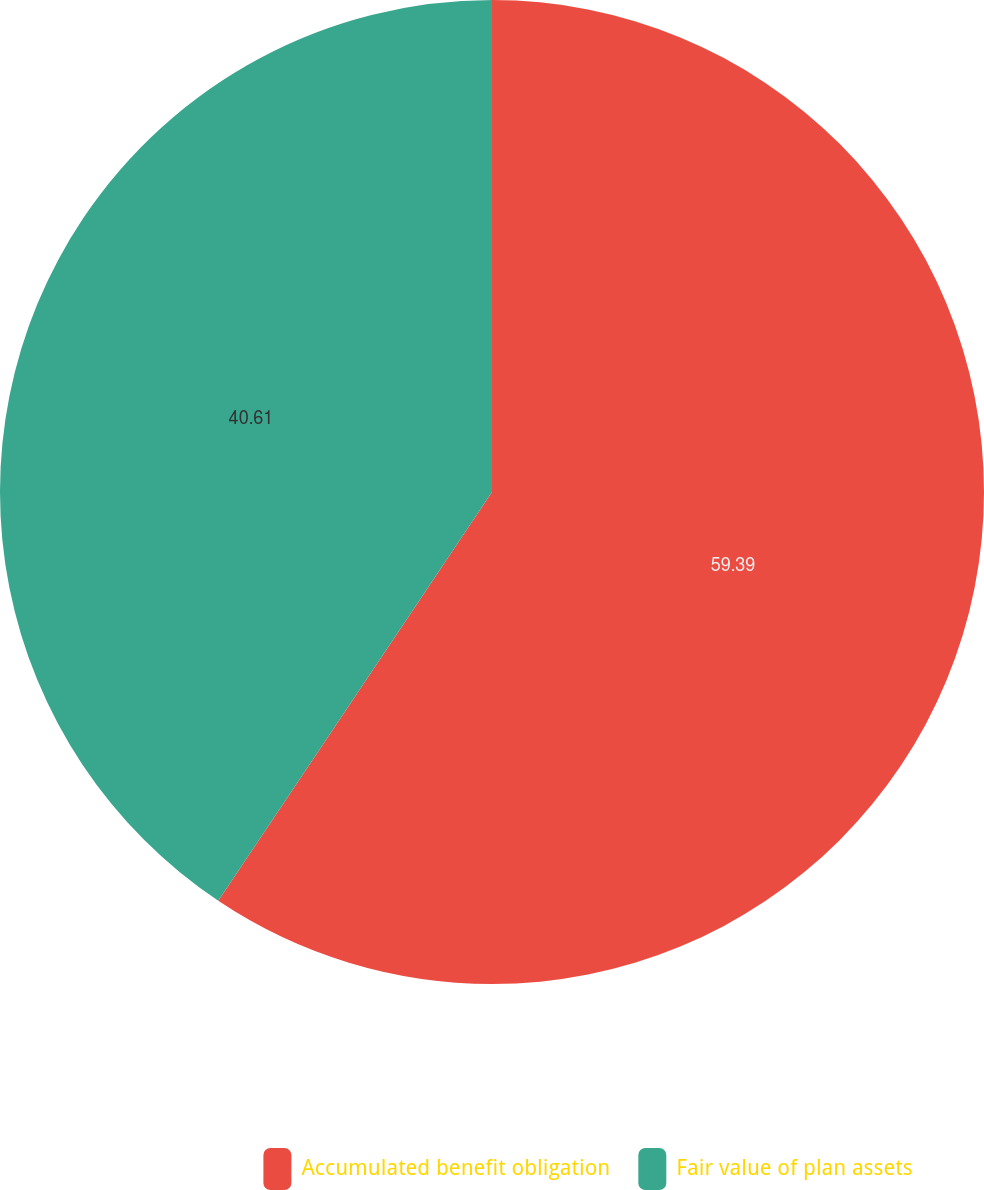<chart> <loc_0><loc_0><loc_500><loc_500><pie_chart><fcel>Accumulated benefit obligation<fcel>Fair value of plan assets<nl><fcel>59.39%<fcel>40.61%<nl></chart> 